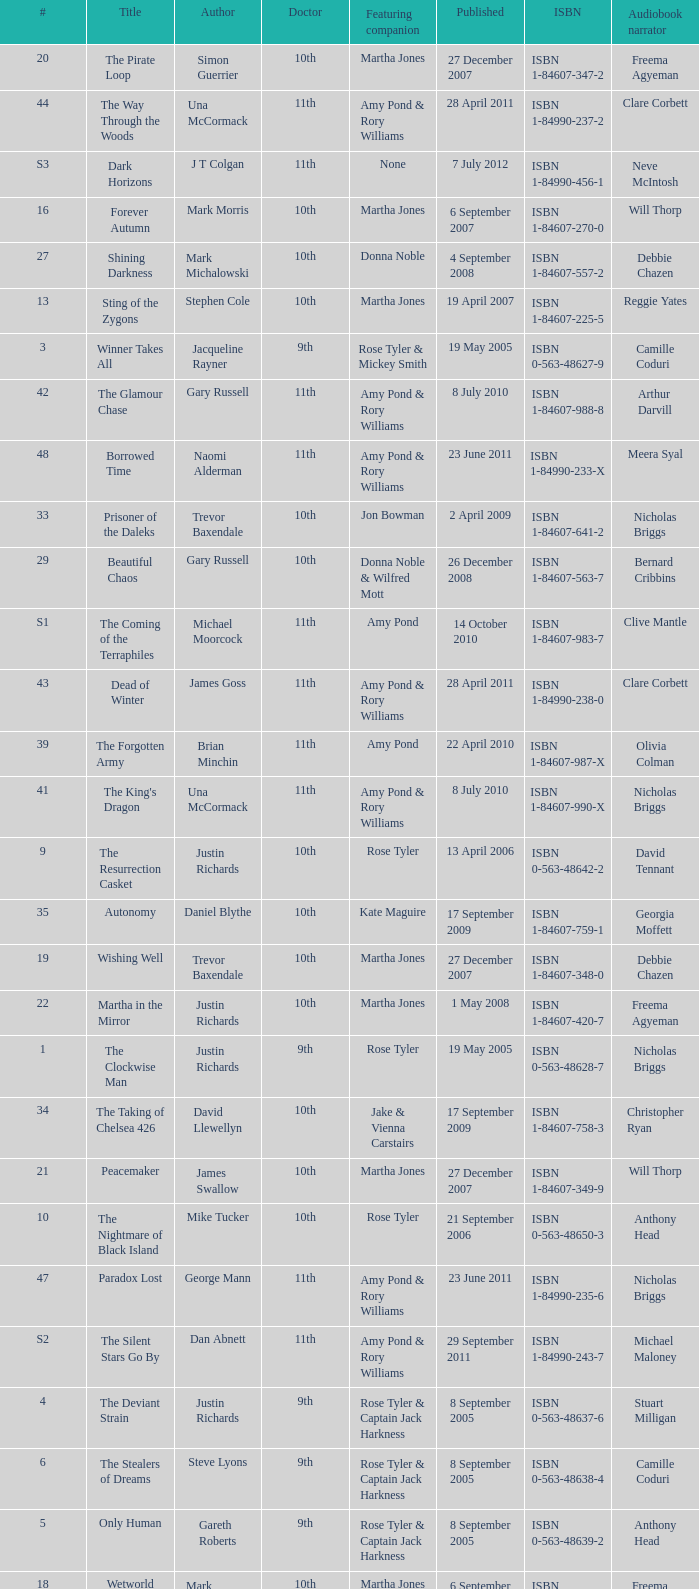Who are the featuring companions of number 3? Rose Tyler & Mickey Smith. 